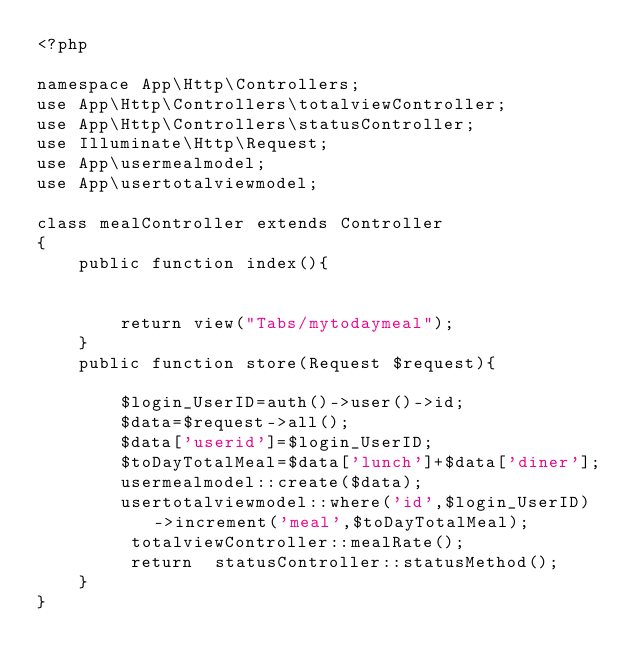<code> <loc_0><loc_0><loc_500><loc_500><_PHP_><?php

namespace App\Http\Controllers;
use App\Http\Controllers\totalviewController;
use App\Http\Controllers\statusController;
use Illuminate\Http\Request;
use App\usermealmodel;
use App\usertotalviewmodel;

class mealController extends Controller
{
    public function index(){


    	return view("Tabs/mytodaymeal");
    }
    public function store(Request $request){

    	$login_UserID=auth()->user()->id;
		$data=$request->all();
		$data['userid']=$login_UserID;
		$toDayTotalMeal=$data['lunch']+$data['diner'];
		usermealmodel::create($data);
		usertotalviewmodel::where('id',$login_UserID)->increment('meal',$toDayTotalMeal);
		 totalviewController::mealRate();
		 return  statusController::statusMethod();
    }
}
</code> 